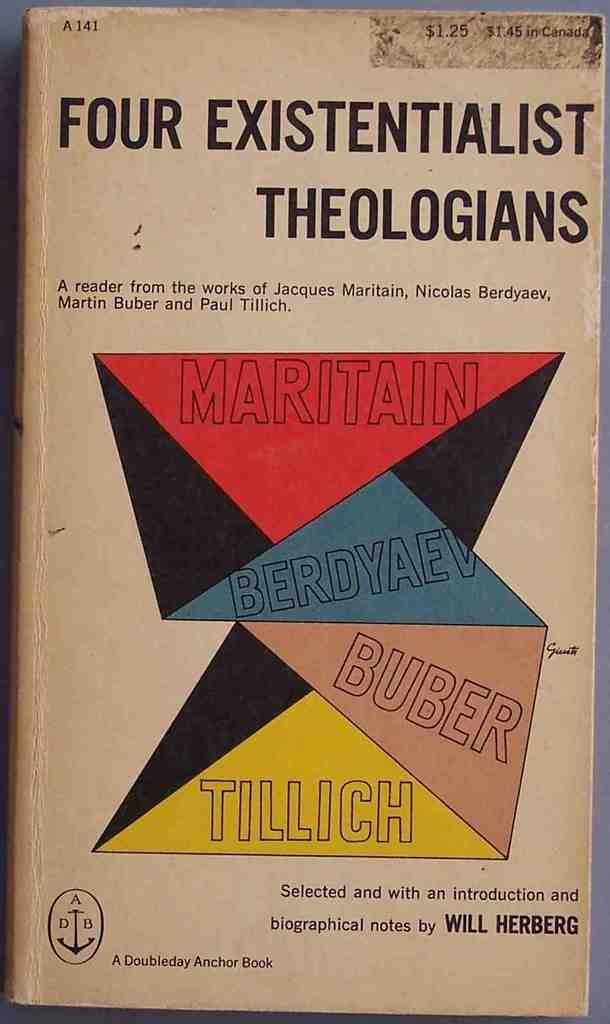<image>
Provide a brief description of the given image. A book titled Four Existentialist Theologians has a colorful cover. 